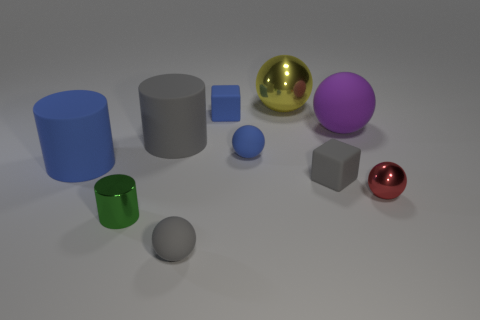Subtract all tiny red shiny balls. How many balls are left? 4 Subtract all purple spheres. How many spheres are left? 4 Subtract all cyan balls. Subtract all gray cubes. How many balls are left? 5 Subtract all blocks. How many objects are left? 8 Subtract all big red metallic balls. Subtract all green objects. How many objects are left? 9 Add 1 matte blocks. How many matte blocks are left? 3 Add 6 blue cylinders. How many blue cylinders exist? 7 Subtract 1 gray cubes. How many objects are left? 9 